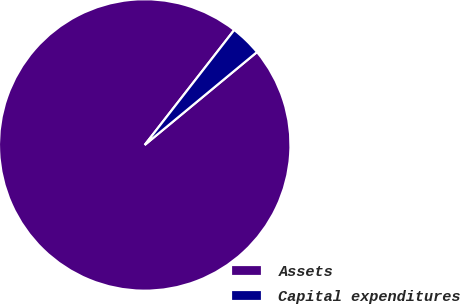<chart> <loc_0><loc_0><loc_500><loc_500><pie_chart><fcel>Assets<fcel>Capital expenditures<nl><fcel>96.53%<fcel>3.47%<nl></chart> 